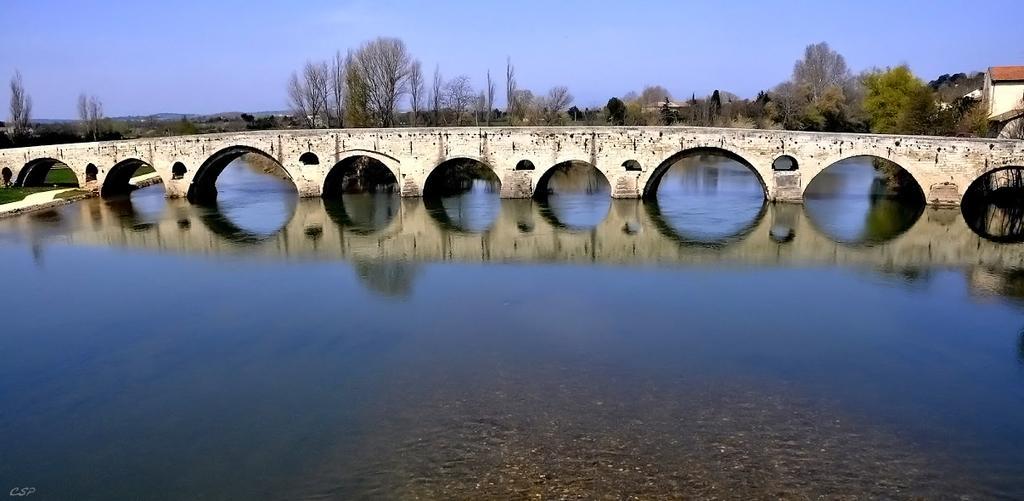Describe this image in one or two sentences. We can see water, grass and bridge. In the background we can see trees, houses and sky. 